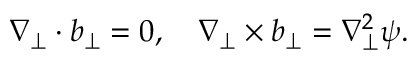Convert formula to latex. <formula><loc_0><loc_0><loc_500><loc_500>\nabla _ { \perp } \cdot b _ { \perp } = 0 , \quad \nabla _ { \perp } \times b _ { \perp } = \nabla _ { \perp } ^ { 2 } \psi .</formula> 